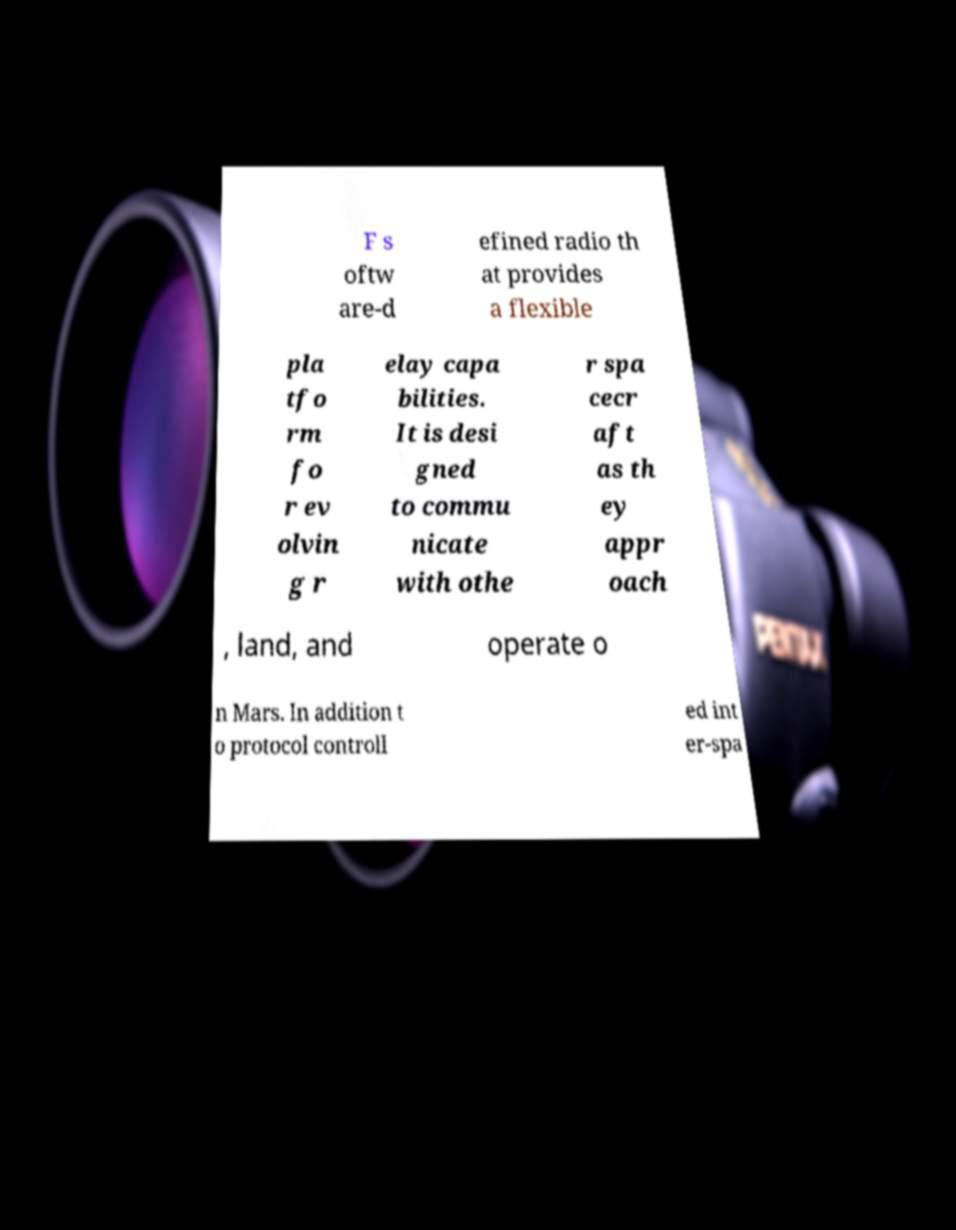For documentation purposes, I need the text within this image transcribed. Could you provide that? F s oftw are-d efined radio th at provides a flexible pla tfo rm fo r ev olvin g r elay capa bilities. It is desi gned to commu nicate with othe r spa cecr aft as th ey appr oach , land, and operate o n Mars. In addition t o protocol controll ed int er-spa 